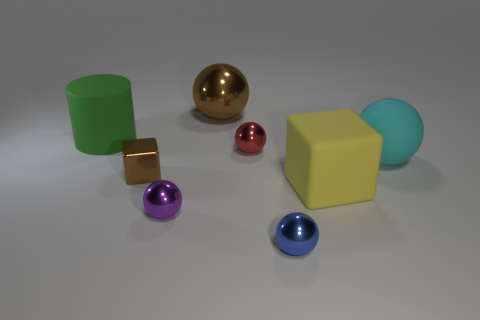Subtract 2 balls. How many balls are left? 3 Subtract all brown spheres. How many spheres are left? 4 Subtract all cyan matte balls. How many balls are left? 4 Subtract all yellow balls. Subtract all cyan blocks. How many balls are left? 5 Add 2 large balls. How many objects exist? 10 Subtract all balls. How many objects are left? 3 Add 2 cyan matte objects. How many cyan matte objects are left? 3 Add 6 small purple shiny cubes. How many small purple shiny cubes exist? 6 Subtract 0 blue blocks. How many objects are left? 8 Subtract all small brown matte blocks. Subtract all spheres. How many objects are left? 3 